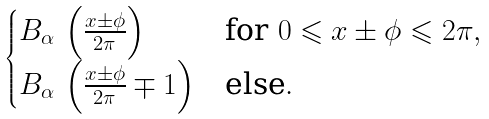Convert formula to latex. <formula><loc_0><loc_0><loc_500><loc_500>\begin{cases} B _ { \alpha } \, \left ( \frac { x \pm \phi } { 2 \pi } \right ) & \text {for $0\leqslant x\pm\phi\leqslant2\pi$} , \\ B _ { \alpha } \, \left ( \frac { x \pm \phi } { 2 \pi } \mp 1 \right ) & \text {else} . \end{cases}</formula> 